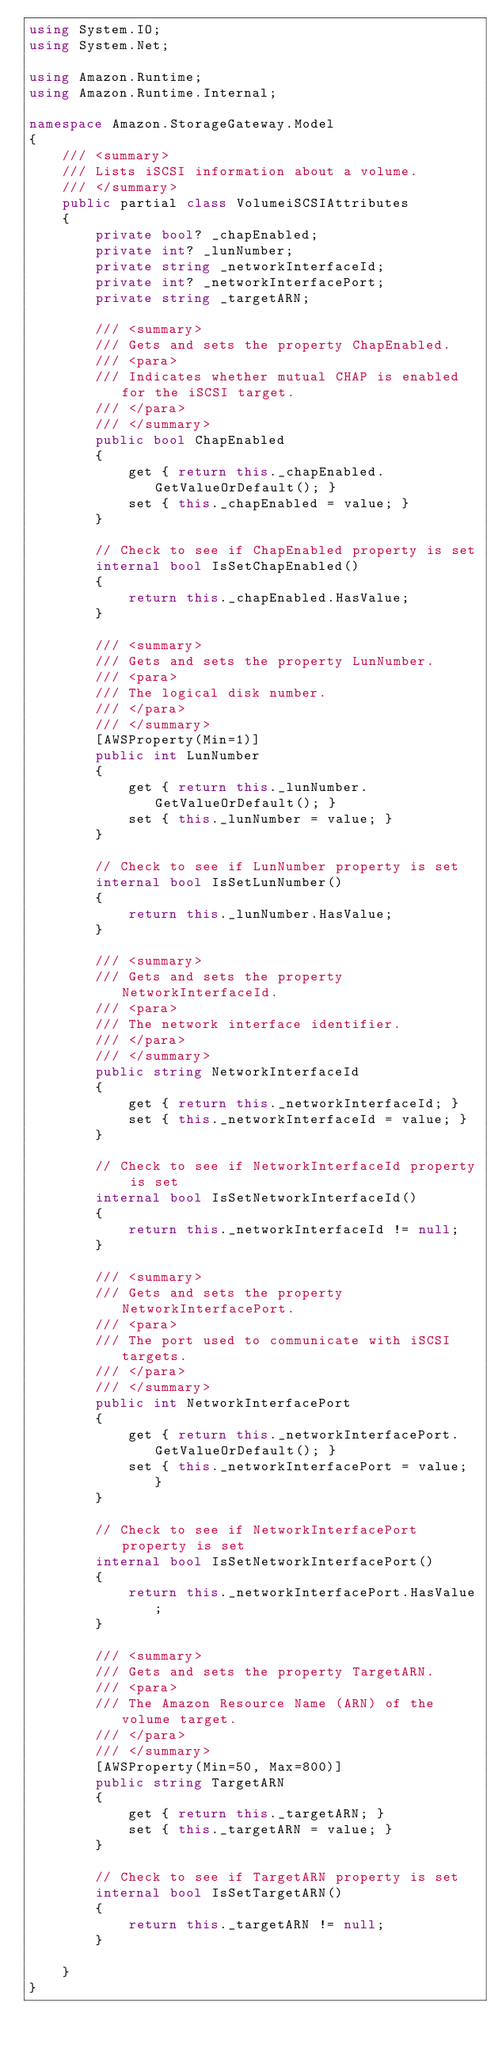Convert code to text. <code><loc_0><loc_0><loc_500><loc_500><_C#_>using System.IO;
using System.Net;

using Amazon.Runtime;
using Amazon.Runtime.Internal;

namespace Amazon.StorageGateway.Model
{
    /// <summary>
    /// Lists iSCSI information about a volume.
    /// </summary>
    public partial class VolumeiSCSIAttributes
    {
        private bool? _chapEnabled;
        private int? _lunNumber;
        private string _networkInterfaceId;
        private int? _networkInterfacePort;
        private string _targetARN;

        /// <summary>
        /// Gets and sets the property ChapEnabled. 
        /// <para>
        /// Indicates whether mutual CHAP is enabled for the iSCSI target.
        /// </para>
        /// </summary>
        public bool ChapEnabled
        {
            get { return this._chapEnabled.GetValueOrDefault(); }
            set { this._chapEnabled = value; }
        }

        // Check to see if ChapEnabled property is set
        internal bool IsSetChapEnabled()
        {
            return this._chapEnabled.HasValue; 
        }

        /// <summary>
        /// Gets and sets the property LunNumber. 
        /// <para>
        /// The logical disk number.
        /// </para>
        /// </summary>
        [AWSProperty(Min=1)]
        public int LunNumber
        {
            get { return this._lunNumber.GetValueOrDefault(); }
            set { this._lunNumber = value; }
        }

        // Check to see if LunNumber property is set
        internal bool IsSetLunNumber()
        {
            return this._lunNumber.HasValue; 
        }

        /// <summary>
        /// Gets and sets the property NetworkInterfaceId. 
        /// <para>
        /// The network interface identifier.
        /// </para>
        /// </summary>
        public string NetworkInterfaceId
        {
            get { return this._networkInterfaceId; }
            set { this._networkInterfaceId = value; }
        }

        // Check to see if NetworkInterfaceId property is set
        internal bool IsSetNetworkInterfaceId()
        {
            return this._networkInterfaceId != null;
        }

        /// <summary>
        /// Gets and sets the property NetworkInterfacePort. 
        /// <para>
        /// The port used to communicate with iSCSI targets.
        /// </para>
        /// </summary>
        public int NetworkInterfacePort
        {
            get { return this._networkInterfacePort.GetValueOrDefault(); }
            set { this._networkInterfacePort = value; }
        }

        // Check to see if NetworkInterfacePort property is set
        internal bool IsSetNetworkInterfacePort()
        {
            return this._networkInterfacePort.HasValue; 
        }

        /// <summary>
        /// Gets and sets the property TargetARN. 
        /// <para>
        /// The Amazon Resource Name (ARN) of the volume target.
        /// </para>
        /// </summary>
        [AWSProperty(Min=50, Max=800)]
        public string TargetARN
        {
            get { return this._targetARN; }
            set { this._targetARN = value; }
        }

        // Check to see if TargetARN property is set
        internal bool IsSetTargetARN()
        {
            return this._targetARN != null;
        }

    }
}</code> 